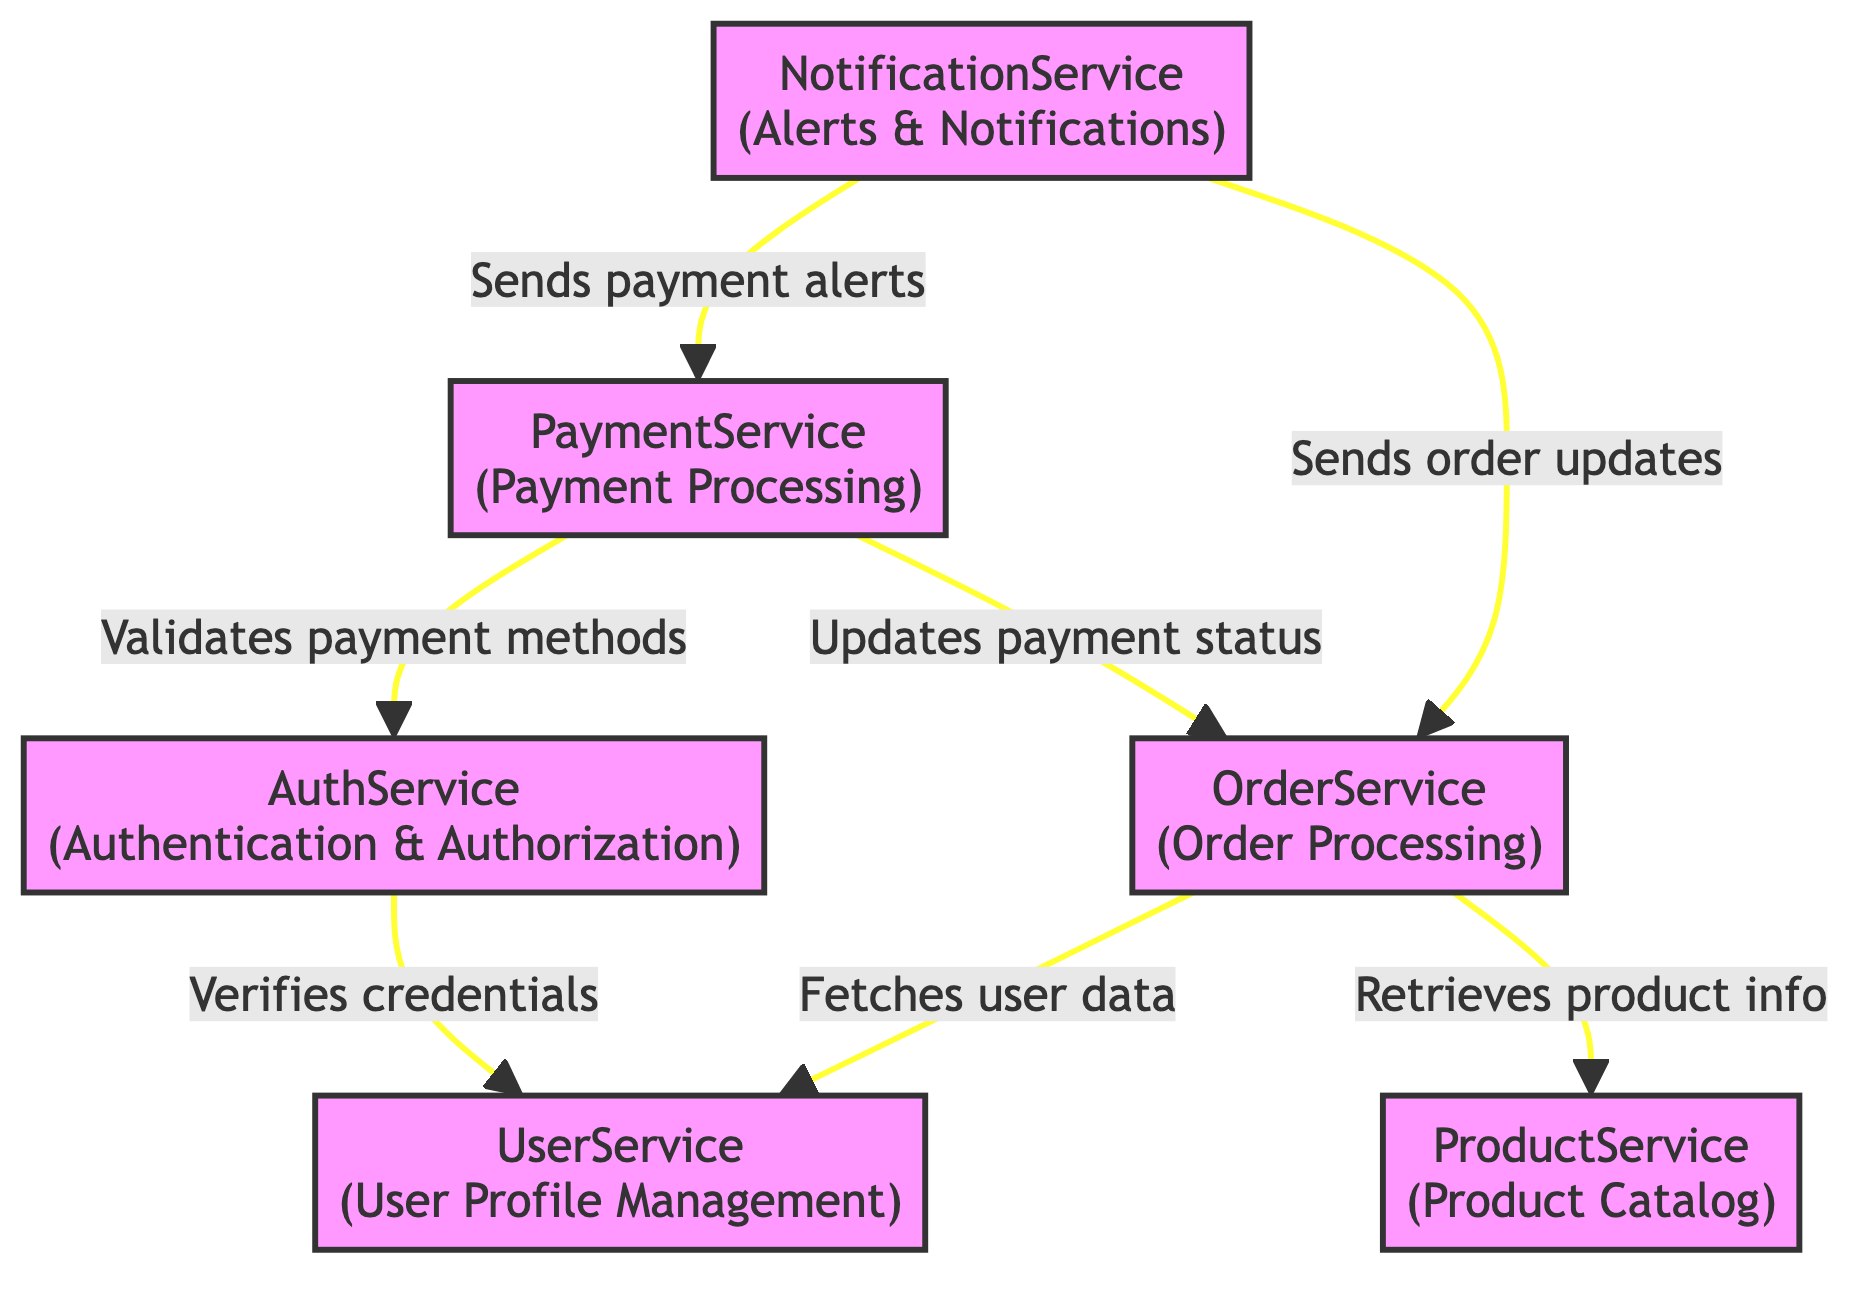What is the total number of microservices depicted in the diagram? The diagram includes a list of nodes categorized as microservices. Counting them, there are six identified: AuthService, UserService, ProductService, OrderService, PaymentService, and NotificationService.
Answer: 6 Which microservice is responsible for handling user authentication? Referring to the nodes in the diagram, the AuthService is specifically described as responsible for user authentication and authorization using OAuth 2.0.
Answer: AuthService What is the relationship between the OrderService and UserService? The edge connecting OrderService to UserService depicts that OrderService fetches user data to attach user-specific details to orders. This indicates a direct dependency on user data.
Answer: Fetches user data How many edges are there in the diagram? The edges represent the connections between microservices. By counting these edges, we see there are seven connections indicating interactions among the services.
Answer: 7 What action does the NotificationService perform regarding the OrderService? The diagram specifies that NotificationService sends order confirmation and status updates to users, indicating its role in user communication through order processing.
Answer: Sends order updates Which microservice validates user payment methods? Based on the edges illustrated in the diagram, the PaymentService is tasked with validating user payment methods using user authentication tokens provided by AuthService.
Answer: PaymentService What is the flow direction between the PaymentService and OrderService? The directional edge from PaymentService to OrderService indicates that the PaymentService updates the order payment status after successful transactions, establishing a clear flow of information.
Answer: Updates payment status Which microservice interacts with both OrderService and PaymentService? The NotificationService is connected to both microservices, implying it has interactions with them for sending notifications related to order and payment statuses.
Answer: NotificationService 